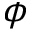Convert formula to latex. <formula><loc_0><loc_0><loc_500><loc_500>\phi</formula> 